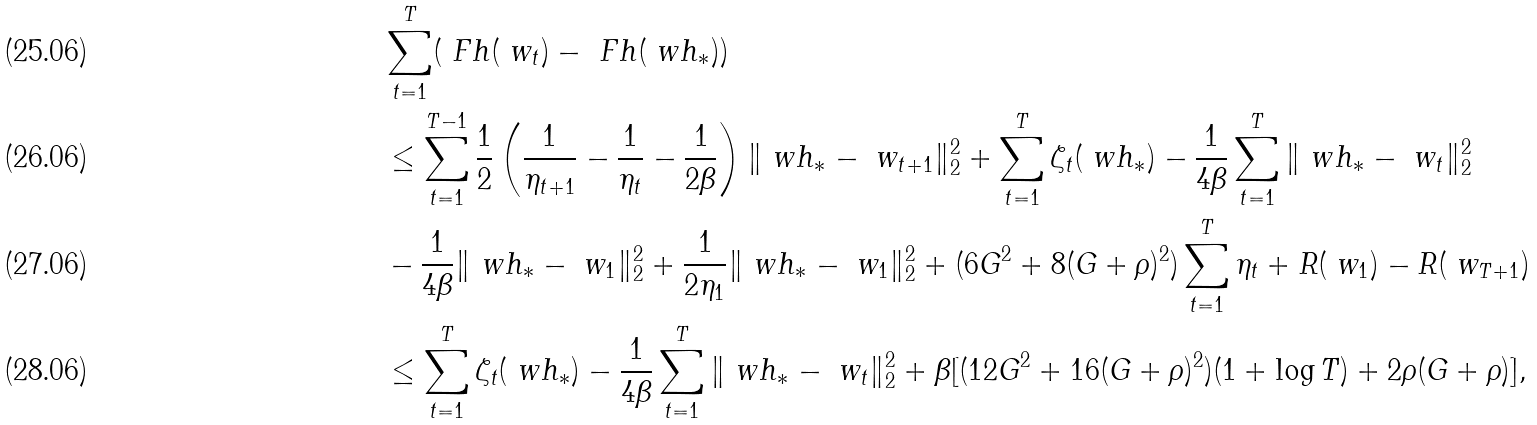Convert formula to latex. <formula><loc_0><loc_0><loc_500><loc_500>& \sum _ { t = 1 } ^ { T } ( \ F h ( \ w _ { t } ) - \ F h ( \ w h _ { * } ) ) \\ & \leq \sum _ { t = 1 } ^ { T - 1 } \frac { 1 } { 2 } \left ( \frac { 1 } { \eta _ { t + 1 } } - \frac { 1 } { \eta _ { t } } - \frac { 1 } { 2 \beta } \right ) \| \ w h _ { * } - \ w _ { t + 1 } \| _ { 2 } ^ { 2 } + \sum _ { t = 1 } ^ { T } \zeta _ { t } ( \ w h _ { * } ) - \frac { 1 } { 4 \beta } \sum _ { t = 1 } ^ { T } \| \ w h _ { * } - \ w _ { t } \| _ { 2 } ^ { 2 } \\ & - \frac { 1 } { 4 \beta } \| \ w h _ { * } - \ w _ { 1 } \| _ { 2 } ^ { 2 } + \frac { 1 } { 2 \eta _ { 1 } } \| \ w h _ { * } - \ w _ { 1 } \| _ { 2 } ^ { 2 } + ( 6 G ^ { 2 } + 8 ( G + \rho ) ^ { 2 } ) \sum _ { t = 1 } ^ { T } \eta _ { t } + R ( \ w _ { 1 } ) - R ( \ w _ { T + 1 } ) \\ & \leq \sum _ { t = 1 } ^ { T } \zeta _ { t } ( \ w h _ { * } ) - \frac { 1 } { 4 \beta } \sum _ { t = 1 } ^ { T } \| \ w h _ { * } - \ w _ { t } \| _ { 2 } ^ { 2 } + \beta [ ( 1 2 G ^ { 2 } + 1 6 ( G + \rho ) ^ { 2 } ) ( 1 + \log T ) + 2 \rho ( G + \rho ) ] ,</formula> 